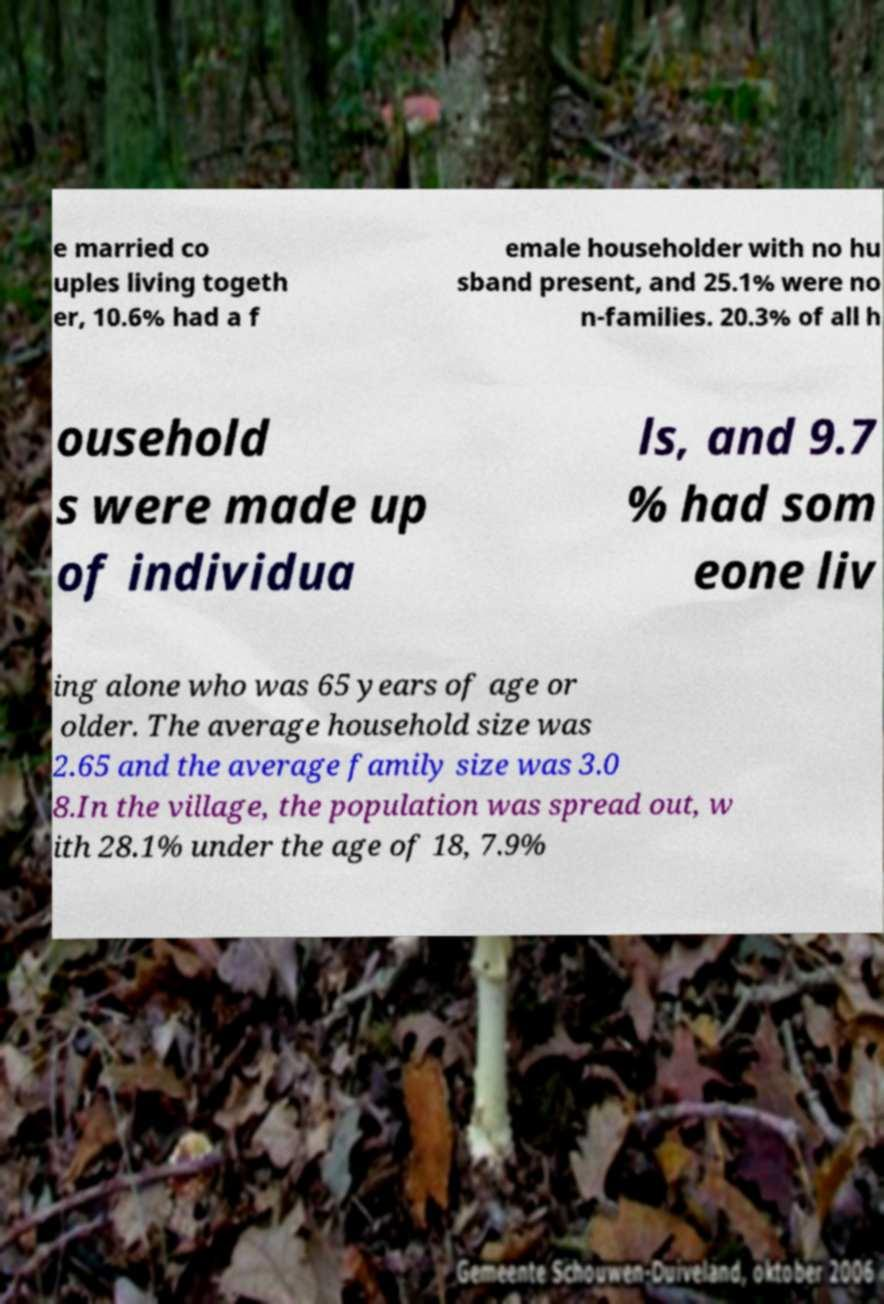Can you read and provide the text displayed in the image?This photo seems to have some interesting text. Can you extract and type it out for me? e married co uples living togeth er, 10.6% had a f emale householder with no hu sband present, and 25.1% were no n-families. 20.3% of all h ousehold s were made up of individua ls, and 9.7 % had som eone liv ing alone who was 65 years of age or older. The average household size was 2.65 and the average family size was 3.0 8.In the village, the population was spread out, w ith 28.1% under the age of 18, 7.9% 